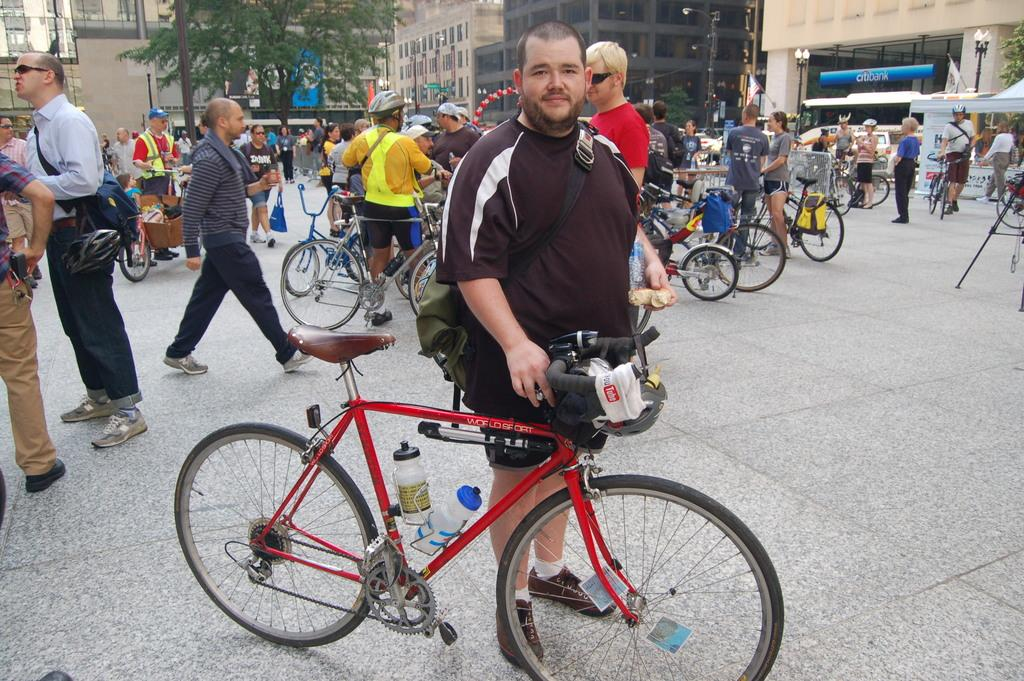How many people can be seen in the image? There are many people in the image. What are the people doing in the image? The people are standing beside bicycles. Where is the scene taking place? The scene appears to be on a street. What can be seen in the background of the image? There are buildings visible in the background. Can you tell me how many faucets are visible in the image? There are no faucets present in the image. What type of face can be seen on the buildings in the background? There are no faces visible on the buildings in the background; they are just structures. 